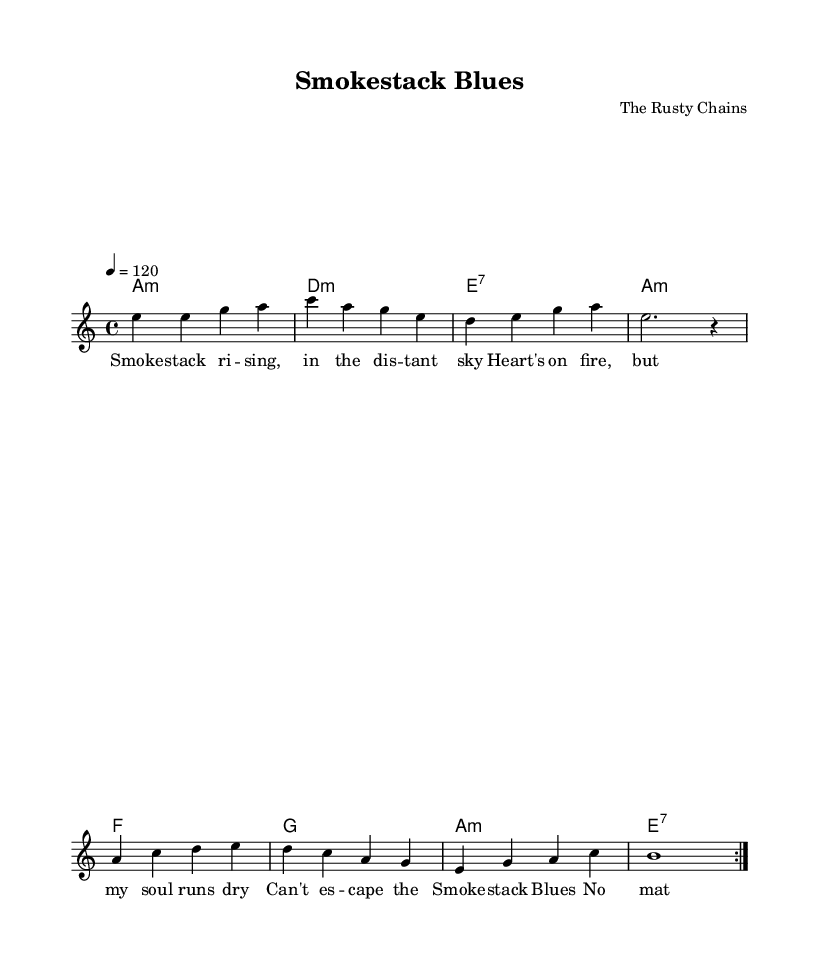What is the key signature of this music? The key signature is A minor, identified by the absence of sharps or flats, indicating that the piece is focused around A minor tonalities.
Answer: A minor What is the time signature of this music? The time signature is 4/4, which is commonly used in blues music allowing for a steady beat and four beats in each measure.
Answer: 4/4 What is the tempo marking of this music? The tempo marking is 120 beats per minute, which is specified in the score indicating a moderately fast pace suitable for a blues feel.
Answer: 120 How many measures are repeated in the melody? The melody section repeats over two measures as indicated by the \repeat volta 2 command in the music notation.
Answer: 2 What type of seventh chord appears in the harmonies? The seventh chord specified in the harmonies is an E seventh chord, as denoted by "e:7" in the chord progression.
Answer: E seventh What lyrical theme is present in this blues song? The lyrical theme revolves around the struggle and emotional turmoil connected to the "Smokestack Blues," hinting at feelings of despair and longing as expressed in the lyrics.
Answer: Emotional turmoil What musical feature aligns with traditional blues structure in this piece? The piece adheres to traditional blues structures through the use of a call-and-response pattern evident in the melody and lyrics, characteristic of the genre's storytelling approach.
Answer: Call-and-response pattern 